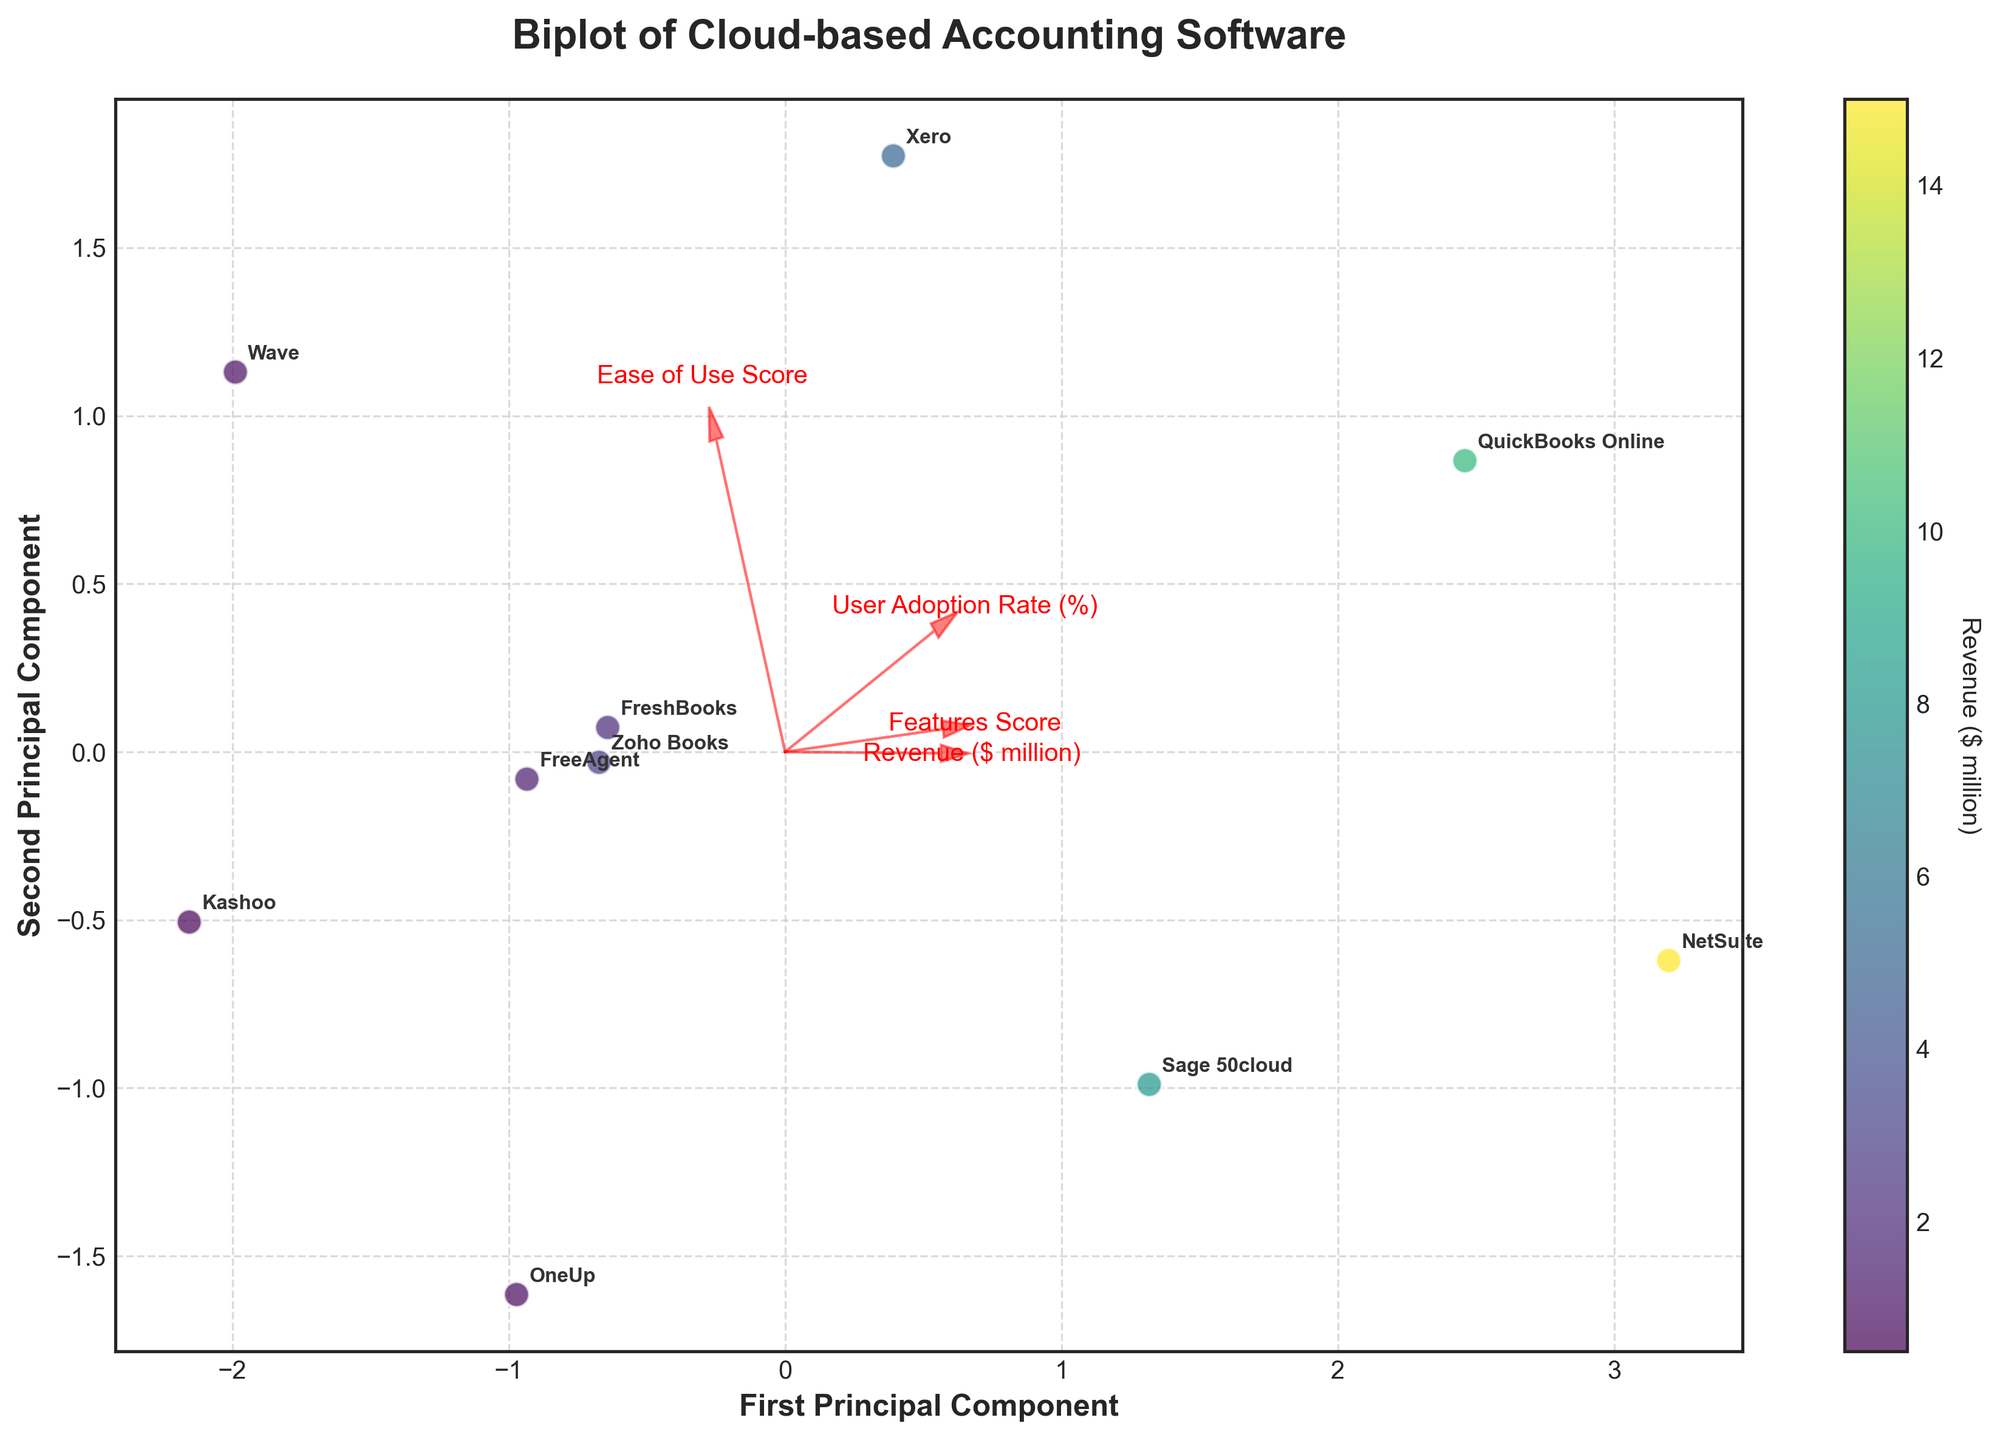How many companies are plotted in the biplot? By counting the number of labeled data points or annotations on the plot, we can determine the number of companies. Each company label represents one data point on the plot.
Answer: 10 What does the color of the data points represent? The color of the data points is explained in the figure, typically in the color bar or legend. Here, it specifies 'Revenue ($ million)'.
Answer: Revenue ($ million) Which company has the highest user adoption rate? By locating the point with the highest position along the user adoption rate arrow and matching it to its label, we can identify the company with the highest user adoption rate. According to the table, 'QuickBooks Online' has the highest user adoption rate at 85%.
Answer: QuickBooks Online Do companies with higher revenues generally have higher user adoption rates? To determine this, observe how the data points are distributed concerning both the revenue-related colors and their proximity to the user adoption rate arrow. Generally, companies with higher revenue tend to be positioned closer to the direction indicated by the user adoption rate vector.
Answer: Yes Which component contributes more to the first principal component, 'Features Score' or 'Ease of Use Score'? By comparing the lengths of the arrows for 'Features Score' and 'Ease of Use Score' along the first principal component axis, we can determine which one has a greater contribution. The longer the arrow, the greater its contribution.
Answer: Features Score Are there any companies with similar user adoption rates but vastly different revenues? Comparing positions of data points along the user adoption rate vector that align horizontally can help spot companies with similar user adoption rates. Different colors representing the revenue would indicate disparities in revenues. For instance, if two points align close to the user adoption rate vector but have different colors, it indicates their revenues differ.
Answer: Yes, for example, 'QuickBooks Online' and 'NetSuite' Which company has the lowest ease of use score, and what does this indicate in the plot? By finding the company label closest to the vector representing the ease of use score with the smallest arrow length, you can identify the lowest score. 'Sage 50cloud' has the lowest ease of use score at 7. This usually indicates the position farthest below the direction of ease of use score arrow.
Answer: Sage 50cloud Which two features are most positively correlated according to the biplot? By examining the angles between the arrows, the features with arrows pointing in similar directions or forming the smallest angles between them are positively correlated. Smaller angles indicate positive correlation.
Answer: User Adoption Rate (%) and Revenue ($ million) Which principal component explains more variability in the data? The principal component with the longer axis or larger variance explained can be identified, usually indicated in the plot's legend or title. Typically, the first principal component captures more variability.
Answer: First principal component Based on the plot, which feature seems to have the least influence on differentiating companies? The feature associated with the shortest arrow in the biplot contributes the least to differentiating the companies, indicating a lower variance explained by this feature.
Answer: Ease of Use Score 